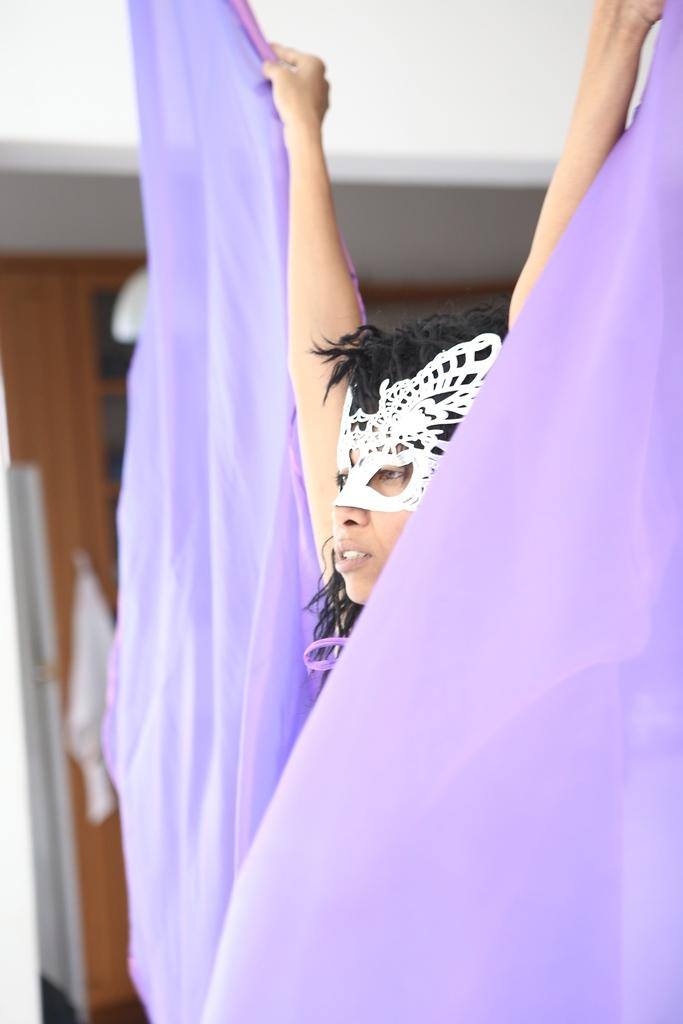Who is the main subject in the image? There is a woman in the picture. What is the woman doing in the image? The woman is wearing different costumes and raising a hand with a violet-colored cloth. What can be seen in the background of the image? There is a wooden wall in the background of the image. Are there any objects attached to the wooden wall? Yes, there is a rack on the wooden wall. What is the price of the sky in the image? There is no sky present in the image, and therefore no price can be determined. Can you describe the bite marks on the wooden wall in the image? There are no bite marks visible on the wooden wall in the image. 